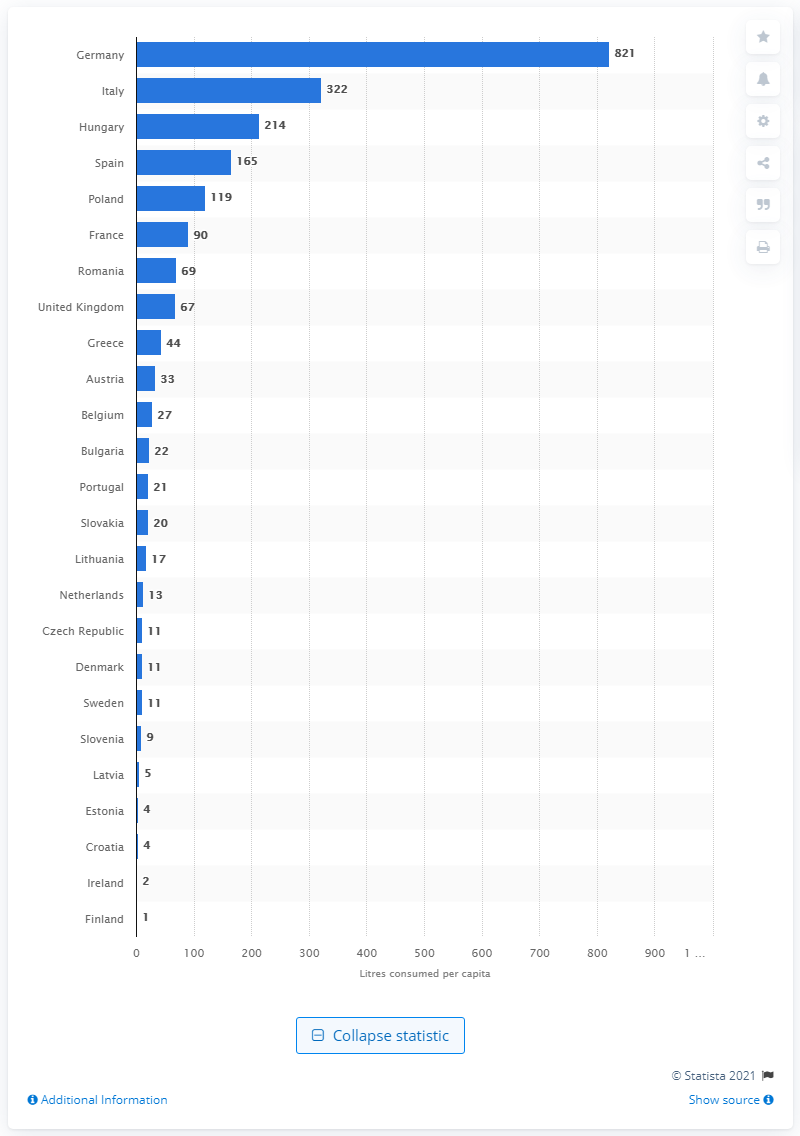Indicate a few pertinent items in this graphic. According to data from 2016, Germany had the highest number of natural mineral waters. In 2016, Germany had a total of 821 natural mineral water sources. 